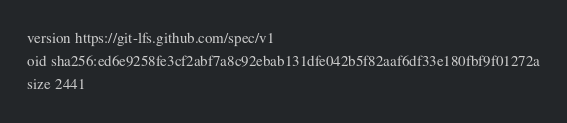<code> <loc_0><loc_0><loc_500><loc_500><_YAML_>version https://git-lfs.github.com/spec/v1
oid sha256:ed6e9258fe3cf2abf7a8c92ebab131dfe042b5f82aaf6df33e180fbf9f01272a
size 2441
</code> 